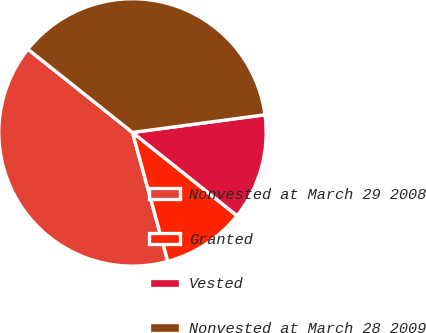Convert chart. <chart><loc_0><loc_0><loc_500><loc_500><pie_chart><fcel>Nonvested at March 29 2008<fcel>Granted<fcel>Vested<fcel>Nonvested at March 28 2009<nl><fcel>39.95%<fcel>10.05%<fcel>12.81%<fcel>37.19%<nl></chart> 